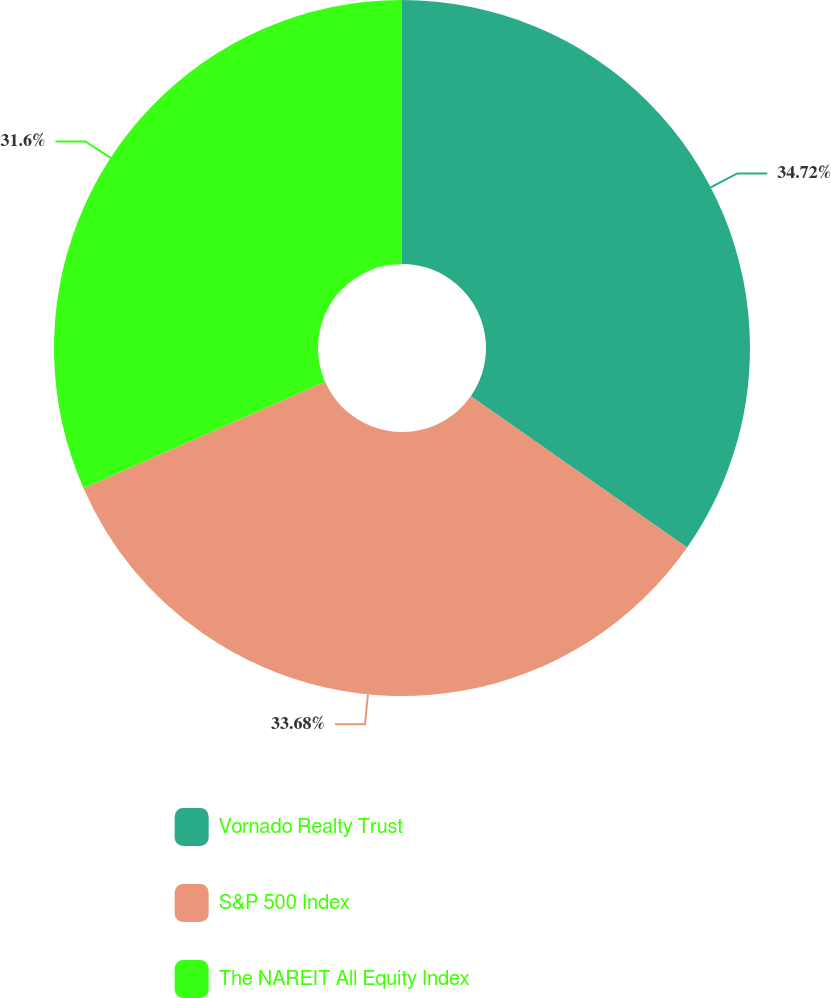<chart> <loc_0><loc_0><loc_500><loc_500><pie_chart><fcel>Vornado Realty Trust<fcel>S&P 500 Index<fcel>The NAREIT All Equity Index<nl><fcel>34.72%<fcel>33.68%<fcel>31.6%<nl></chart> 